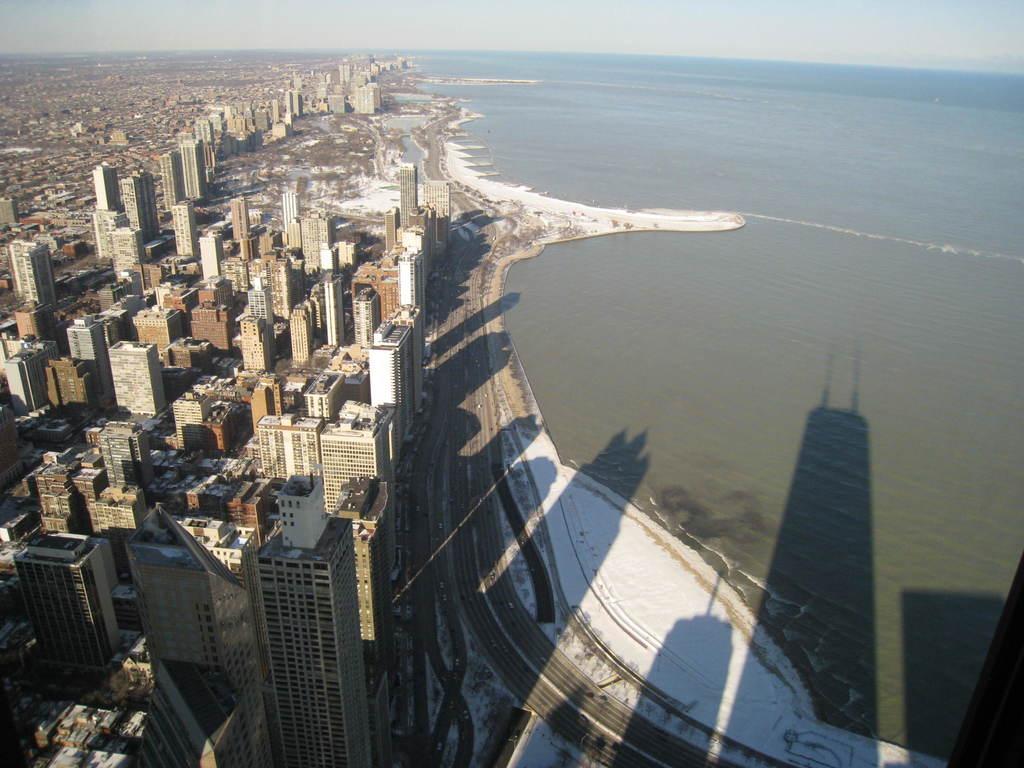Describe this image in one or two sentences. In this image I can see buildings and a road. On the right side I can see the water and the sky. 